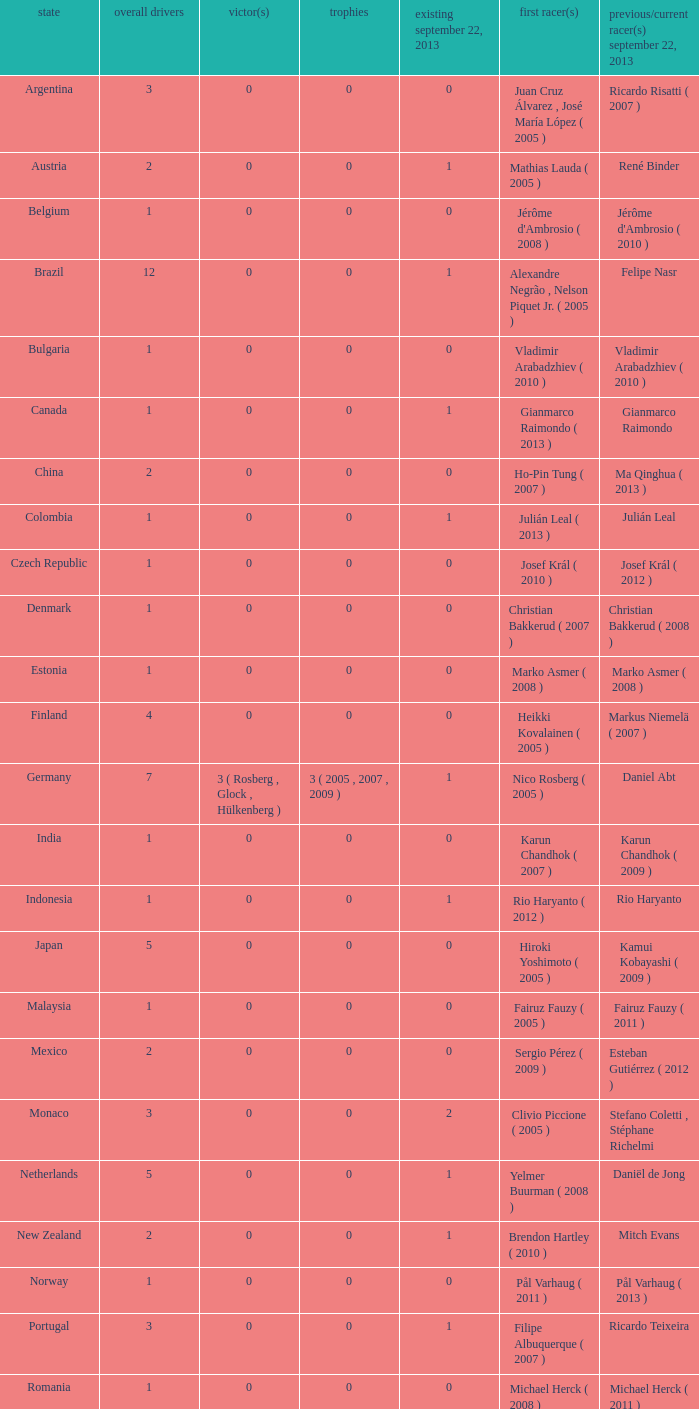How many entries are there for first driver for Canada? 1.0. 